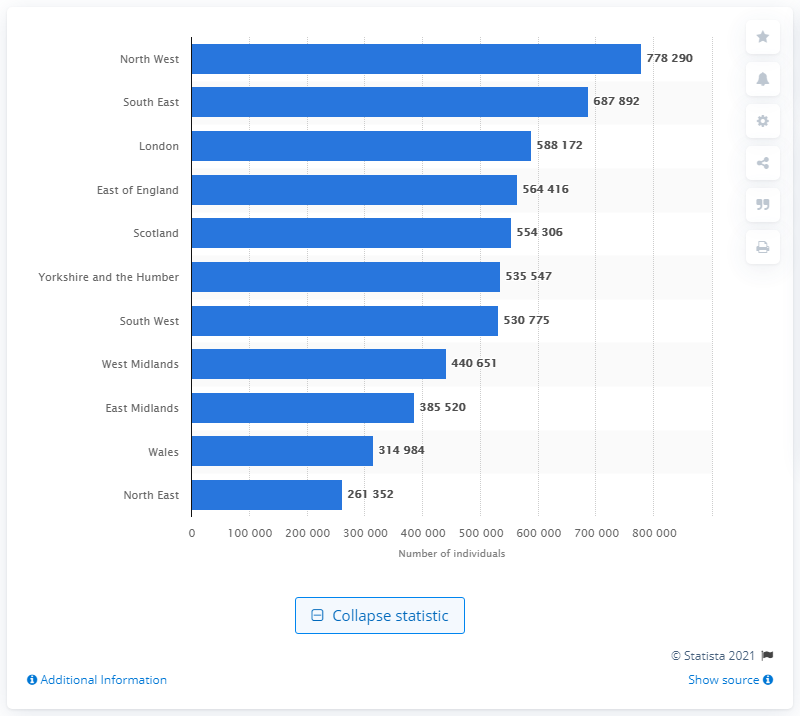How many people in the South East had asthma in 2015?
 687892 